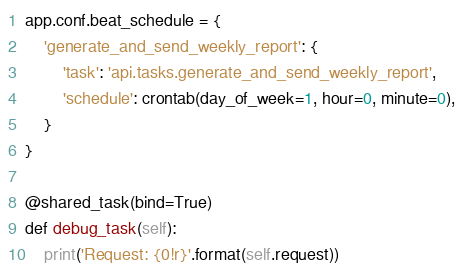Convert code to text. <code><loc_0><loc_0><loc_500><loc_500><_Python_>

app.conf.beat_schedule = {
    'generate_and_send_weekly_report': {
        'task': 'api.tasks.generate_and_send_weekly_report',
        'schedule': crontab(day_of_week=1, hour=0, minute=0),
    }
}

@shared_task(bind=True)
def debug_task(self):
    print('Request: {0!r}'.format(self.request))
</code> 